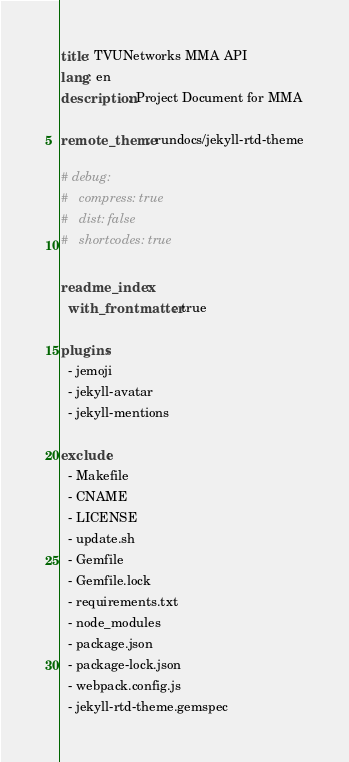<code> <loc_0><loc_0><loc_500><loc_500><_YAML_>title: TVUNetworks MMA API
lang: en
description: Project Document for MMA

remote_theme: rundocs/jekyll-rtd-theme

# debug:
#   compress: true
#   dist: false
#   shortcodes: true

readme_index:
  with_frontmatter: true

plugins:
  - jemoji
  - jekyll-avatar
  - jekyll-mentions

exclude:
  - Makefile
  - CNAME
  - LICENSE
  - update.sh
  - Gemfile
  - Gemfile.lock
  - requirements.txt
  - node_modules
  - package.json
  - package-lock.json
  - webpack.config.js
  - jekyll-rtd-theme.gemspec
</code> 